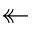Convert formula to latex. <formula><loc_0><loc_0><loc_500><loc_500>\twoheadleftarrow</formula> 